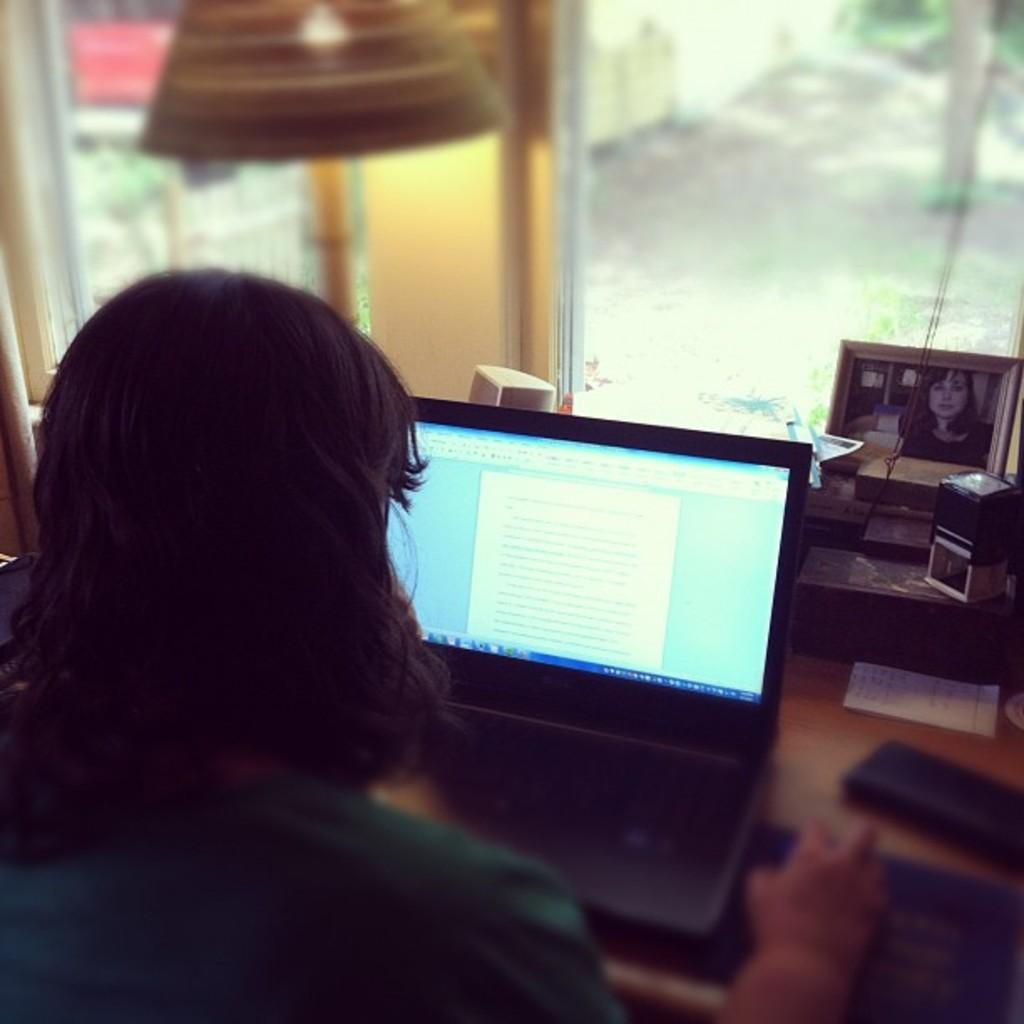Who or what is present in the image? There is a person in the image. What object can be seen in the image that the person might be using? There is a table in the image, and a laptop is on the table. What else is on the table besides the laptop? There is a paper and a photo frame on the table. What type of structure can be seen in the image that allows light to enter? There is a glass window in the image. Can you see any boats or the moon reflected in the glass window in the image? There are no boats or the moon visible in the image, nor are they reflected in the glass window. 